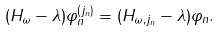<formula> <loc_0><loc_0><loc_500><loc_500>\| ( H _ { \omega } - \lambda ) \varphi _ { n } ^ { ( j _ { n } ) } \| = \| ( H _ { \omega , j _ { n } } - \lambda ) \varphi _ { n } \| .</formula> 